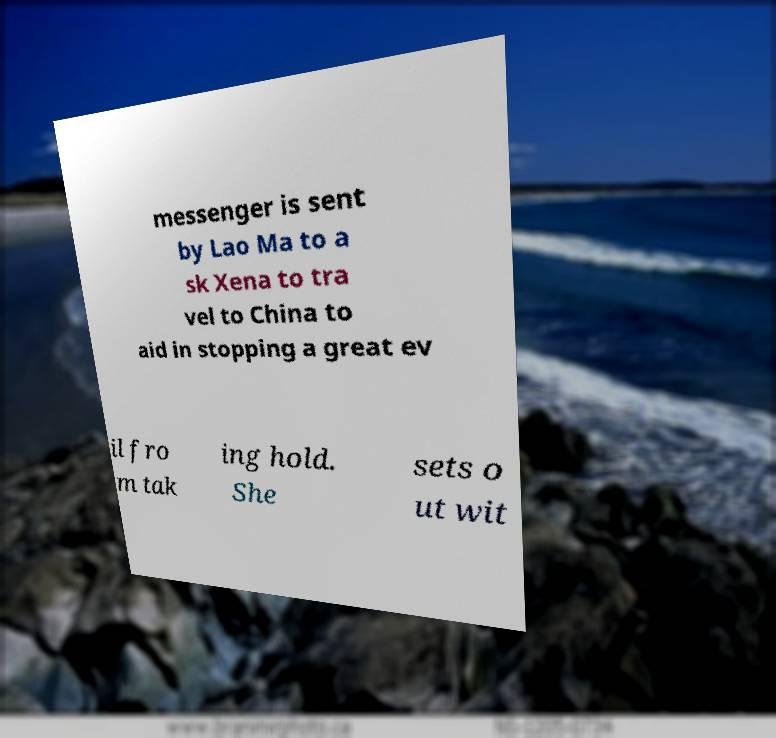Could you extract and type out the text from this image? messenger is sent by Lao Ma to a sk Xena to tra vel to China to aid in stopping a great ev il fro m tak ing hold. She sets o ut wit 